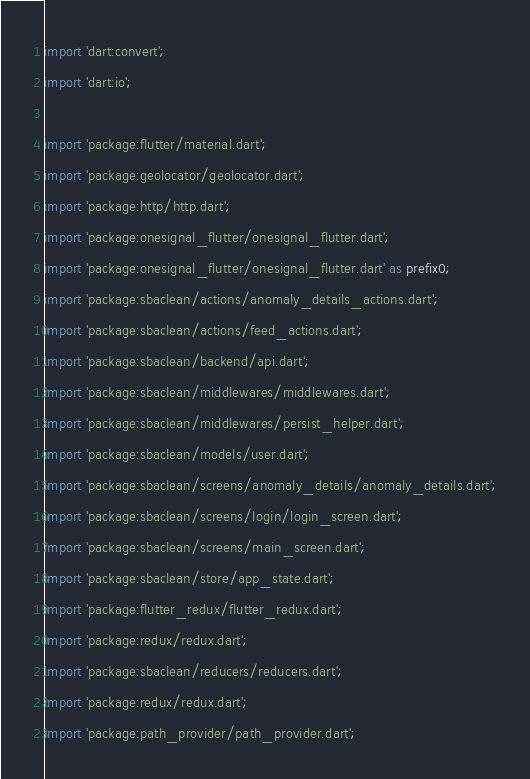<code> <loc_0><loc_0><loc_500><loc_500><_Dart_>import 'dart:convert';
import 'dart:io';

import 'package:flutter/material.dart';
import 'package:geolocator/geolocator.dart';
import 'package:http/http.dart';
import 'package:onesignal_flutter/onesignal_flutter.dart';
import 'package:onesignal_flutter/onesignal_flutter.dart' as prefix0;
import 'package:sbaclean/actions/anomaly_details_actions.dart';
import 'package:sbaclean/actions/feed_actions.dart';
import 'package:sbaclean/backend/api.dart';
import 'package:sbaclean/middlewares/middlewares.dart';
import 'package:sbaclean/middlewares/persist_helper.dart';
import 'package:sbaclean/models/user.dart';
import 'package:sbaclean/screens/anomaly_details/anomaly_details.dart';
import 'package:sbaclean/screens/login/login_screen.dart';
import 'package:sbaclean/screens/main_screen.dart';
import 'package:sbaclean/store/app_state.dart';
import 'package:flutter_redux/flutter_redux.dart';
import 'package:redux/redux.dart';
import 'package:sbaclean/reducers/reducers.dart';
import 'package:redux/redux.dart';
import 'package:path_provider/path_provider.dart';</code> 